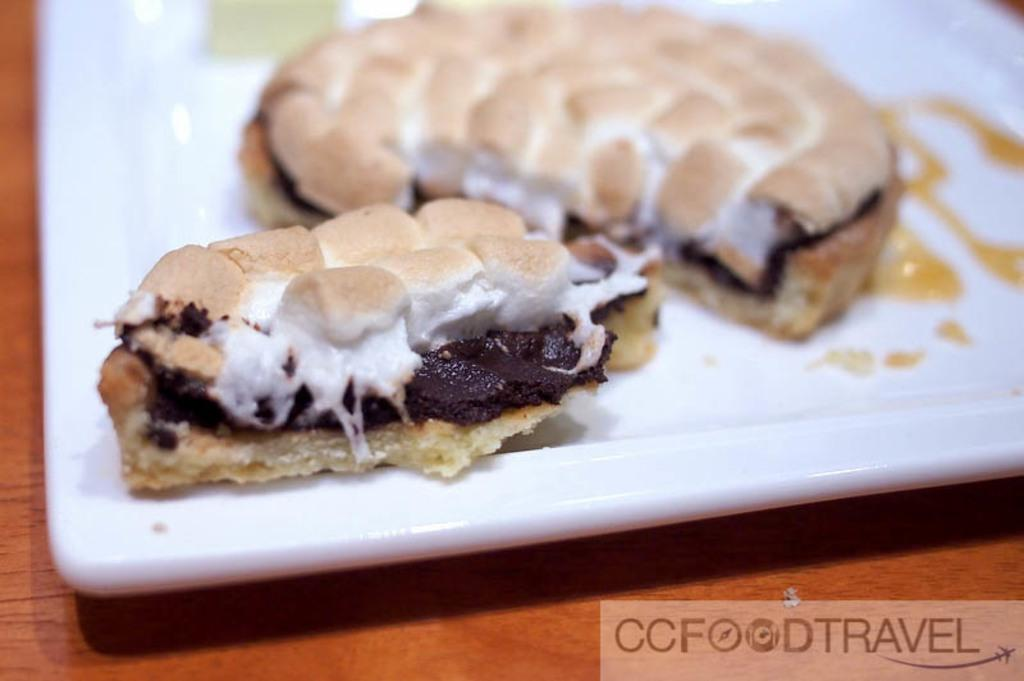What object is present on the table in the image? There is a plate on the table in the image. What is the purpose of the plate in the image? The plate is used to hold food items. Can you describe the food items on the plate? Unfortunately, the specific food items cannot be determined from the provided facts. What type of hospital is depicted in the image? There is no hospital present in the image; it features a plate on a table with food items. What role does the government play in the image? There is no reference to the government in the image; it only shows a plate with food items on a table. 